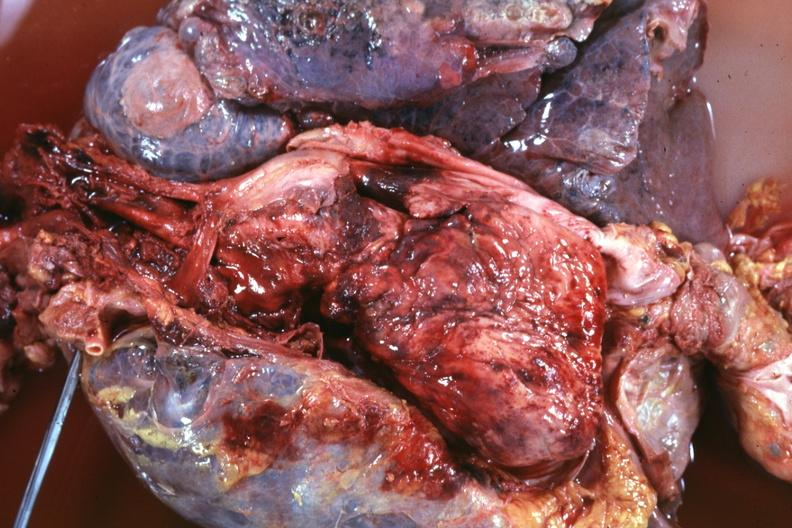does this image show thoracic organs dissected to show super cava and region of tumor invasion quite good?
Answer the question using a single word or phrase. Yes 